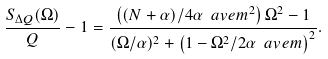Convert formula to latex. <formula><loc_0><loc_0><loc_500><loc_500>\frac { S _ { \Delta Q } ( \Omega ) } { Q } - 1 = \frac { \left ( ( N + \alpha ) / 4 \alpha \ a v e { m } ^ { 2 } \right ) \Omega ^ { 2 } - 1 } { ( \Omega / \alpha ) ^ { 2 } + \left ( 1 - \Omega ^ { 2 } / 2 \alpha \ a v e { m } \right ) ^ { 2 } } .</formula> 